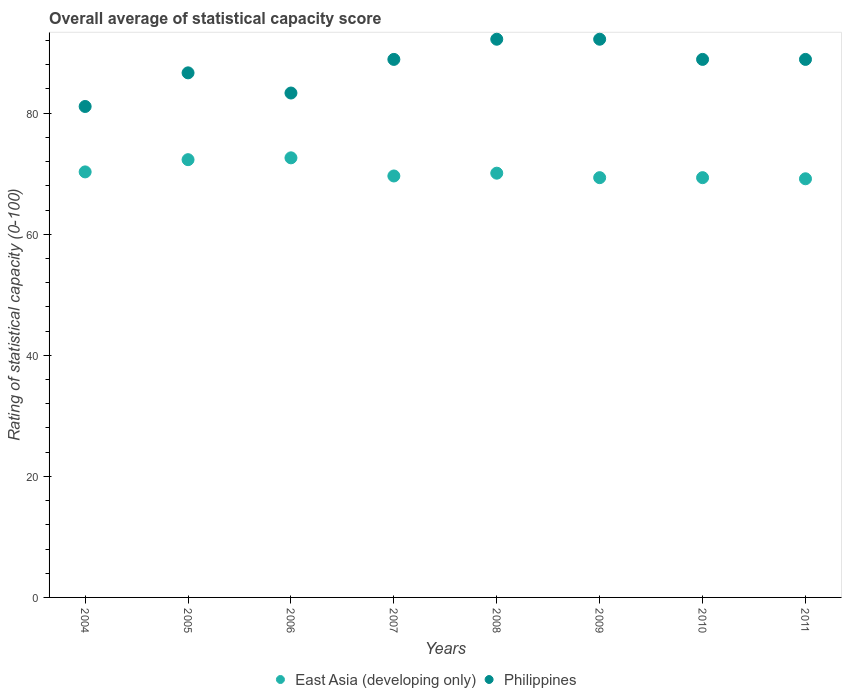How many different coloured dotlines are there?
Provide a succinct answer. 2. Is the number of dotlines equal to the number of legend labels?
Provide a succinct answer. Yes. What is the rating of statistical capacity in Philippines in 2008?
Offer a terse response. 92.22. Across all years, what is the maximum rating of statistical capacity in East Asia (developing only)?
Provide a short and direct response. 72.63. Across all years, what is the minimum rating of statistical capacity in Philippines?
Provide a succinct answer. 81.11. In which year was the rating of statistical capacity in East Asia (developing only) maximum?
Provide a succinct answer. 2006. What is the total rating of statistical capacity in East Asia (developing only) in the graph?
Ensure brevity in your answer.  562.85. What is the difference between the rating of statistical capacity in East Asia (developing only) in 2008 and that in 2009?
Give a very brief answer. 0.74. What is the difference between the rating of statistical capacity in Philippines in 2006 and the rating of statistical capacity in East Asia (developing only) in 2010?
Your answer should be very brief. 13.98. What is the average rating of statistical capacity in Philippines per year?
Ensure brevity in your answer.  87.78. In the year 2011, what is the difference between the rating of statistical capacity in Philippines and rating of statistical capacity in East Asia (developing only)?
Provide a short and direct response. 19.72. In how many years, is the rating of statistical capacity in Philippines greater than 76?
Provide a short and direct response. 8. What is the ratio of the rating of statistical capacity in East Asia (developing only) in 2004 to that in 2009?
Your answer should be very brief. 1.01. Is the difference between the rating of statistical capacity in Philippines in 2004 and 2005 greater than the difference between the rating of statistical capacity in East Asia (developing only) in 2004 and 2005?
Give a very brief answer. No. What is the difference between the highest and the second highest rating of statistical capacity in East Asia (developing only)?
Your answer should be compact. 0.3. What is the difference between the highest and the lowest rating of statistical capacity in East Asia (developing only)?
Ensure brevity in your answer.  3.46. In how many years, is the rating of statistical capacity in Philippines greater than the average rating of statistical capacity in Philippines taken over all years?
Give a very brief answer. 5. Is the sum of the rating of statistical capacity in East Asia (developing only) in 2004 and 2007 greater than the maximum rating of statistical capacity in Philippines across all years?
Your answer should be compact. Yes. Does the rating of statistical capacity in East Asia (developing only) monotonically increase over the years?
Give a very brief answer. No. Is the rating of statistical capacity in East Asia (developing only) strictly greater than the rating of statistical capacity in Philippines over the years?
Make the answer very short. No. How many years are there in the graph?
Your answer should be compact. 8. What is the difference between two consecutive major ticks on the Y-axis?
Provide a succinct answer. 20. Where does the legend appear in the graph?
Provide a succinct answer. Bottom center. How are the legend labels stacked?
Offer a very short reply. Horizontal. What is the title of the graph?
Keep it short and to the point. Overall average of statistical capacity score. What is the label or title of the X-axis?
Keep it short and to the point. Years. What is the label or title of the Y-axis?
Offer a terse response. Rating of statistical capacity (0-100). What is the Rating of statistical capacity (0-100) of East Asia (developing only) in 2004?
Make the answer very short. 70.3. What is the Rating of statistical capacity (0-100) of Philippines in 2004?
Keep it short and to the point. 81.11. What is the Rating of statistical capacity (0-100) in East Asia (developing only) in 2005?
Ensure brevity in your answer.  72.32. What is the Rating of statistical capacity (0-100) of Philippines in 2005?
Give a very brief answer. 86.67. What is the Rating of statistical capacity (0-100) of East Asia (developing only) in 2006?
Your response must be concise. 72.63. What is the Rating of statistical capacity (0-100) of Philippines in 2006?
Offer a terse response. 83.33. What is the Rating of statistical capacity (0-100) in East Asia (developing only) in 2007?
Your answer should be compact. 69.63. What is the Rating of statistical capacity (0-100) of Philippines in 2007?
Provide a short and direct response. 88.89. What is the Rating of statistical capacity (0-100) of East Asia (developing only) in 2008?
Provide a short and direct response. 70.09. What is the Rating of statistical capacity (0-100) in Philippines in 2008?
Keep it short and to the point. 92.22. What is the Rating of statistical capacity (0-100) of East Asia (developing only) in 2009?
Your answer should be compact. 69.35. What is the Rating of statistical capacity (0-100) in Philippines in 2009?
Give a very brief answer. 92.22. What is the Rating of statistical capacity (0-100) in East Asia (developing only) in 2010?
Make the answer very short. 69.35. What is the Rating of statistical capacity (0-100) in Philippines in 2010?
Make the answer very short. 88.89. What is the Rating of statistical capacity (0-100) of East Asia (developing only) in 2011?
Your answer should be very brief. 69.17. What is the Rating of statistical capacity (0-100) in Philippines in 2011?
Offer a very short reply. 88.89. Across all years, what is the maximum Rating of statistical capacity (0-100) in East Asia (developing only)?
Offer a terse response. 72.63. Across all years, what is the maximum Rating of statistical capacity (0-100) of Philippines?
Give a very brief answer. 92.22. Across all years, what is the minimum Rating of statistical capacity (0-100) in East Asia (developing only)?
Your answer should be very brief. 69.17. Across all years, what is the minimum Rating of statistical capacity (0-100) in Philippines?
Offer a terse response. 81.11. What is the total Rating of statistical capacity (0-100) of East Asia (developing only) in the graph?
Provide a short and direct response. 562.85. What is the total Rating of statistical capacity (0-100) of Philippines in the graph?
Offer a terse response. 702.22. What is the difference between the Rating of statistical capacity (0-100) in East Asia (developing only) in 2004 and that in 2005?
Give a very brief answer. -2.02. What is the difference between the Rating of statistical capacity (0-100) of Philippines in 2004 and that in 2005?
Your answer should be compact. -5.56. What is the difference between the Rating of statistical capacity (0-100) of East Asia (developing only) in 2004 and that in 2006?
Keep it short and to the point. -2.32. What is the difference between the Rating of statistical capacity (0-100) of Philippines in 2004 and that in 2006?
Your answer should be very brief. -2.22. What is the difference between the Rating of statistical capacity (0-100) in East Asia (developing only) in 2004 and that in 2007?
Keep it short and to the point. 0.67. What is the difference between the Rating of statistical capacity (0-100) in Philippines in 2004 and that in 2007?
Your answer should be compact. -7.78. What is the difference between the Rating of statistical capacity (0-100) in East Asia (developing only) in 2004 and that in 2008?
Make the answer very short. 0.21. What is the difference between the Rating of statistical capacity (0-100) in Philippines in 2004 and that in 2008?
Ensure brevity in your answer.  -11.11. What is the difference between the Rating of statistical capacity (0-100) of East Asia (developing only) in 2004 and that in 2009?
Give a very brief answer. 0.95. What is the difference between the Rating of statistical capacity (0-100) in Philippines in 2004 and that in 2009?
Provide a short and direct response. -11.11. What is the difference between the Rating of statistical capacity (0-100) in East Asia (developing only) in 2004 and that in 2010?
Keep it short and to the point. 0.95. What is the difference between the Rating of statistical capacity (0-100) in Philippines in 2004 and that in 2010?
Your response must be concise. -7.78. What is the difference between the Rating of statistical capacity (0-100) in East Asia (developing only) in 2004 and that in 2011?
Your answer should be very brief. 1.14. What is the difference between the Rating of statistical capacity (0-100) in Philippines in 2004 and that in 2011?
Keep it short and to the point. -7.78. What is the difference between the Rating of statistical capacity (0-100) of East Asia (developing only) in 2005 and that in 2006?
Give a very brief answer. -0.3. What is the difference between the Rating of statistical capacity (0-100) in East Asia (developing only) in 2005 and that in 2007?
Make the answer very short. 2.69. What is the difference between the Rating of statistical capacity (0-100) of Philippines in 2005 and that in 2007?
Offer a terse response. -2.22. What is the difference between the Rating of statistical capacity (0-100) in East Asia (developing only) in 2005 and that in 2008?
Provide a succinct answer. 2.23. What is the difference between the Rating of statistical capacity (0-100) in Philippines in 2005 and that in 2008?
Provide a short and direct response. -5.56. What is the difference between the Rating of statistical capacity (0-100) of East Asia (developing only) in 2005 and that in 2009?
Give a very brief answer. 2.97. What is the difference between the Rating of statistical capacity (0-100) in Philippines in 2005 and that in 2009?
Keep it short and to the point. -5.56. What is the difference between the Rating of statistical capacity (0-100) of East Asia (developing only) in 2005 and that in 2010?
Offer a terse response. 2.97. What is the difference between the Rating of statistical capacity (0-100) in Philippines in 2005 and that in 2010?
Your answer should be compact. -2.22. What is the difference between the Rating of statistical capacity (0-100) of East Asia (developing only) in 2005 and that in 2011?
Provide a succinct answer. 3.16. What is the difference between the Rating of statistical capacity (0-100) of Philippines in 2005 and that in 2011?
Give a very brief answer. -2.22. What is the difference between the Rating of statistical capacity (0-100) of East Asia (developing only) in 2006 and that in 2007?
Your answer should be compact. 3. What is the difference between the Rating of statistical capacity (0-100) in Philippines in 2006 and that in 2007?
Give a very brief answer. -5.56. What is the difference between the Rating of statistical capacity (0-100) in East Asia (developing only) in 2006 and that in 2008?
Your response must be concise. 2.53. What is the difference between the Rating of statistical capacity (0-100) in Philippines in 2006 and that in 2008?
Your response must be concise. -8.89. What is the difference between the Rating of statistical capacity (0-100) of East Asia (developing only) in 2006 and that in 2009?
Your answer should be compact. 3.27. What is the difference between the Rating of statistical capacity (0-100) in Philippines in 2006 and that in 2009?
Provide a short and direct response. -8.89. What is the difference between the Rating of statistical capacity (0-100) of East Asia (developing only) in 2006 and that in 2010?
Your answer should be compact. 3.27. What is the difference between the Rating of statistical capacity (0-100) in Philippines in 2006 and that in 2010?
Your answer should be compact. -5.56. What is the difference between the Rating of statistical capacity (0-100) in East Asia (developing only) in 2006 and that in 2011?
Ensure brevity in your answer.  3.46. What is the difference between the Rating of statistical capacity (0-100) in Philippines in 2006 and that in 2011?
Keep it short and to the point. -5.56. What is the difference between the Rating of statistical capacity (0-100) in East Asia (developing only) in 2007 and that in 2008?
Your answer should be very brief. -0.46. What is the difference between the Rating of statistical capacity (0-100) of Philippines in 2007 and that in 2008?
Keep it short and to the point. -3.33. What is the difference between the Rating of statistical capacity (0-100) in East Asia (developing only) in 2007 and that in 2009?
Your answer should be very brief. 0.28. What is the difference between the Rating of statistical capacity (0-100) in Philippines in 2007 and that in 2009?
Offer a very short reply. -3.33. What is the difference between the Rating of statistical capacity (0-100) in East Asia (developing only) in 2007 and that in 2010?
Give a very brief answer. 0.28. What is the difference between the Rating of statistical capacity (0-100) in East Asia (developing only) in 2007 and that in 2011?
Your response must be concise. 0.46. What is the difference between the Rating of statistical capacity (0-100) in Philippines in 2007 and that in 2011?
Your answer should be compact. 0. What is the difference between the Rating of statistical capacity (0-100) of East Asia (developing only) in 2008 and that in 2009?
Offer a very short reply. 0.74. What is the difference between the Rating of statistical capacity (0-100) in Philippines in 2008 and that in 2009?
Make the answer very short. 0. What is the difference between the Rating of statistical capacity (0-100) in East Asia (developing only) in 2008 and that in 2010?
Ensure brevity in your answer.  0.74. What is the difference between the Rating of statistical capacity (0-100) of Philippines in 2008 and that in 2010?
Make the answer very short. 3.33. What is the difference between the Rating of statistical capacity (0-100) of East Asia (developing only) in 2008 and that in 2011?
Give a very brief answer. 0.93. What is the difference between the Rating of statistical capacity (0-100) of Philippines in 2008 and that in 2011?
Make the answer very short. 3.33. What is the difference between the Rating of statistical capacity (0-100) of East Asia (developing only) in 2009 and that in 2011?
Your answer should be compact. 0.19. What is the difference between the Rating of statistical capacity (0-100) in East Asia (developing only) in 2010 and that in 2011?
Offer a very short reply. 0.19. What is the difference between the Rating of statistical capacity (0-100) in Philippines in 2010 and that in 2011?
Provide a short and direct response. 0. What is the difference between the Rating of statistical capacity (0-100) of East Asia (developing only) in 2004 and the Rating of statistical capacity (0-100) of Philippines in 2005?
Your answer should be very brief. -16.36. What is the difference between the Rating of statistical capacity (0-100) of East Asia (developing only) in 2004 and the Rating of statistical capacity (0-100) of Philippines in 2006?
Ensure brevity in your answer.  -13.03. What is the difference between the Rating of statistical capacity (0-100) of East Asia (developing only) in 2004 and the Rating of statistical capacity (0-100) of Philippines in 2007?
Provide a short and direct response. -18.59. What is the difference between the Rating of statistical capacity (0-100) of East Asia (developing only) in 2004 and the Rating of statistical capacity (0-100) of Philippines in 2008?
Your response must be concise. -21.92. What is the difference between the Rating of statistical capacity (0-100) in East Asia (developing only) in 2004 and the Rating of statistical capacity (0-100) in Philippines in 2009?
Offer a very short reply. -21.92. What is the difference between the Rating of statistical capacity (0-100) of East Asia (developing only) in 2004 and the Rating of statistical capacity (0-100) of Philippines in 2010?
Your answer should be compact. -18.59. What is the difference between the Rating of statistical capacity (0-100) in East Asia (developing only) in 2004 and the Rating of statistical capacity (0-100) in Philippines in 2011?
Give a very brief answer. -18.59. What is the difference between the Rating of statistical capacity (0-100) of East Asia (developing only) in 2005 and the Rating of statistical capacity (0-100) of Philippines in 2006?
Ensure brevity in your answer.  -11.01. What is the difference between the Rating of statistical capacity (0-100) of East Asia (developing only) in 2005 and the Rating of statistical capacity (0-100) of Philippines in 2007?
Your answer should be compact. -16.57. What is the difference between the Rating of statistical capacity (0-100) in East Asia (developing only) in 2005 and the Rating of statistical capacity (0-100) in Philippines in 2008?
Your answer should be very brief. -19.9. What is the difference between the Rating of statistical capacity (0-100) of East Asia (developing only) in 2005 and the Rating of statistical capacity (0-100) of Philippines in 2009?
Ensure brevity in your answer.  -19.9. What is the difference between the Rating of statistical capacity (0-100) of East Asia (developing only) in 2005 and the Rating of statistical capacity (0-100) of Philippines in 2010?
Give a very brief answer. -16.57. What is the difference between the Rating of statistical capacity (0-100) of East Asia (developing only) in 2005 and the Rating of statistical capacity (0-100) of Philippines in 2011?
Keep it short and to the point. -16.57. What is the difference between the Rating of statistical capacity (0-100) in East Asia (developing only) in 2006 and the Rating of statistical capacity (0-100) in Philippines in 2007?
Your answer should be compact. -16.26. What is the difference between the Rating of statistical capacity (0-100) of East Asia (developing only) in 2006 and the Rating of statistical capacity (0-100) of Philippines in 2008?
Ensure brevity in your answer.  -19.6. What is the difference between the Rating of statistical capacity (0-100) in East Asia (developing only) in 2006 and the Rating of statistical capacity (0-100) in Philippines in 2009?
Your answer should be compact. -19.6. What is the difference between the Rating of statistical capacity (0-100) in East Asia (developing only) in 2006 and the Rating of statistical capacity (0-100) in Philippines in 2010?
Offer a terse response. -16.26. What is the difference between the Rating of statistical capacity (0-100) of East Asia (developing only) in 2006 and the Rating of statistical capacity (0-100) of Philippines in 2011?
Make the answer very short. -16.26. What is the difference between the Rating of statistical capacity (0-100) of East Asia (developing only) in 2007 and the Rating of statistical capacity (0-100) of Philippines in 2008?
Ensure brevity in your answer.  -22.59. What is the difference between the Rating of statistical capacity (0-100) in East Asia (developing only) in 2007 and the Rating of statistical capacity (0-100) in Philippines in 2009?
Your answer should be very brief. -22.59. What is the difference between the Rating of statistical capacity (0-100) in East Asia (developing only) in 2007 and the Rating of statistical capacity (0-100) in Philippines in 2010?
Keep it short and to the point. -19.26. What is the difference between the Rating of statistical capacity (0-100) of East Asia (developing only) in 2007 and the Rating of statistical capacity (0-100) of Philippines in 2011?
Provide a succinct answer. -19.26. What is the difference between the Rating of statistical capacity (0-100) in East Asia (developing only) in 2008 and the Rating of statistical capacity (0-100) in Philippines in 2009?
Ensure brevity in your answer.  -22.13. What is the difference between the Rating of statistical capacity (0-100) of East Asia (developing only) in 2008 and the Rating of statistical capacity (0-100) of Philippines in 2010?
Give a very brief answer. -18.8. What is the difference between the Rating of statistical capacity (0-100) of East Asia (developing only) in 2008 and the Rating of statistical capacity (0-100) of Philippines in 2011?
Provide a short and direct response. -18.8. What is the difference between the Rating of statistical capacity (0-100) of East Asia (developing only) in 2009 and the Rating of statistical capacity (0-100) of Philippines in 2010?
Your answer should be very brief. -19.54. What is the difference between the Rating of statistical capacity (0-100) of East Asia (developing only) in 2009 and the Rating of statistical capacity (0-100) of Philippines in 2011?
Make the answer very short. -19.54. What is the difference between the Rating of statistical capacity (0-100) in East Asia (developing only) in 2010 and the Rating of statistical capacity (0-100) in Philippines in 2011?
Offer a very short reply. -19.54. What is the average Rating of statistical capacity (0-100) of East Asia (developing only) per year?
Make the answer very short. 70.36. What is the average Rating of statistical capacity (0-100) of Philippines per year?
Offer a terse response. 87.78. In the year 2004, what is the difference between the Rating of statistical capacity (0-100) in East Asia (developing only) and Rating of statistical capacity (0-100) in Philippines?
Provide a succinct answer. -10.81. In the year 2005, what is the difference between the Rating of statistical capacity (0-100) in East Asia (developing only) and Rating of statistical capacity (0-100) in Philippines?
Ensure brevity in your answer.  -14.34. In the year 2006, what is the difference between the Rating of statistical capacity (0-100) of East Asia (developing only) and Rating of statistical capacity (0-100) of Philippines?
Keep it short and to the point. -10.71. In the year 2007, what is the difference between the Rating of statistical capacity (0-100) of East Asia (developing only) and Rating of statistical capacity (0-100) of Philippines?
Give a very brief answer. -19.26. In the year 2008, what is the difference between the Rating of statistical capacity (0-100) of East Asia (developing only) and Rating of statistical capacity (0-100) of Philippines?
Give a very brief answer. -22.13. In the year 2009, what is the difference between the Rating of statistical capacity (0-100) of East Asia (developing only) and Rating of statistical capacity (0-100) of Philippines?
Ensure brevity in your answer.  -22.87. In the year 2010, what is the difference between the Rating of statistical capacity (0-100) in East Asia (developing only) and Rating of statistical capacity (0-100) in Philippines?
Give a very brief answer. -19.54. In the year 2011, what is the difference between the Rating of statistical capacity (0-100) in East Asia (developing only) and Rating of statistical capacity (0-100) in Philippines?
Offer a terse response. -19.72. What is the ratio of the Rating of statistical capacity (0-100) of East Asia (developing only) in 2004 to that in 2005?
Give a very brief answer. 0.97. What is the ratio of the Rating of statistical capacity (0-100) in Philippines in 2004 to that in 2005?
Your answer should be compact. 0.94. What is the ratio of the Rating of statistical capacity (0-100) in Philippines in 2004 to that in 2006?
Your response must be concise. 0.97. What is the ratio of the Rating of statistical capacity (0-100) of East Asia (developing only) in 2004 to that in 2007?
Your answer should be compact. 1.01. What is the ratio of the Rating of statistical capacity (0-100) in Philippines in 2004 to that in 2007?
Keep it short and to the point. 0.91. What is the ratio of the Rating of statistical capacity (0-100) in East Asia (developing only) in 2004 to that in 2008?
Provide a succinct answer. 1. What is the ratio of the Rating of statistical capacity (0-100) of Philippines in 2004 to that in 2008?
Provide a succinct answer. 0.88. What is the ratio of the Rating of statistical capacity (0-100) of East Asia (developing only) in 2004 to that in 2009?
Your response must be concise. 1.01. What is the ratio of the Rating of statistical capacity (0-100) in Philippines in 2004 to that in 2009?
Provide a succinct answer. 0.88. What is the ratio of the Rating of statistical capacity (0-100) in East Asia (developing only) in 2004 to that in 2010?
Give a very brief answer. 1.01. What is the ratio of the Rating of statistical capacity (0-100) in Philippines in 2004 to that in 2010?
Your answer should be very brief. 0.91. What is the ratio of the Rating of statistical capacity (0-100) in East Asia (developing only) in 2004 to that in 2011?
Give a very brief answer. 1.02. What is the ratio of the Rating of statistical capacity (0-100) in Philippines in 2004 to that in 2011?
Provide a short and direct response. 0.91. What is the ratio of the Rating of statistical capacity (0-100) of East Asia (developing only) in 2005 to that in 2006?
Keep it short and to the point. 1. What is the ratio of the Rating of statistical capacity (0-100) in East Asia (developing only) in 2005 to that in 2007?
Offer a terse response. 1.04. What is the ratio of the Rating of statistical capacity (0-100) of Philippines in 2005 to that in 2007?
Ensure brevity in your answer.  0.97. What is the ratio of the Rating of statistical capacity (0-100) in East Asia (developing only) in 2005 to that in 2008?
Keep it short and to the point. 1.03. What is the ratio of the Rating of statistical capacity (0-100) in Philippines in 2005 to that in 2008?
Keep it short and to the point. 0.94. What is the ratio of the Rating of statistical capacity (0-100) in East Asia (developing only) in 2005 to that in 2009?
Keep it short and to the point. 1.04. What is the ratio of the Rating of statistical capacity (0-100) of Philippines in 2005 to that in 2009?
Provide a succinct answer. 0.94. What is the ratio of the Rating of statistical capacity (0-100) in East Asia (developing only) in 2005 to that in 2010?
Your response must be concise. 1.04. What is the ratio of the Rating of statistical capacity (0-100) in Philippines in 2005 to that in 2010?
Provide a short and direct response. 0.97. What is the ratio of the Rating of statistical capacity (0-100) of East Asia (developing only) in 2005 to that in 2011?
Keep it short and to the point. 1.05. What is the ratio of the Rating of statistical capacity (0-100) in East Asia (developing only) in 2006 to that in 2007?
Your response must be concise. 1.04. What is the ratio of the Rating of statistical capacity (0-100) of Philippines in 2006 to that in 2007?
Your answer should be compact. 0.94. What is the ratio of the Rating of statistical capacity (0-100) in East Asia (developing only) in 2006 to that in 2008?
Your response must be concise. 1.04. What is the ratio of the Rating of statistical capacity (0-100) in Philippines in 2006 to that in 2008?
Offer a terse response. 0.9. What is the ratio of the Rating of statistical capacity (0-100) in East Asia (developing only) in 2006 to that in 2009?
Give a very brief answer. 1.05. What is the ratio of the Rating of statistical capacity (0-100) in Philippines in 2006 to that in 2009?
Your answer should be very brief. 0.9. What is the ratio of the Rating of statistical capacity (0-100) in East Asia (developing only) in 2006 to that in 2010?
Keep it short and to the point. 1.05. What is the ratio of the Rating of statistical capacity (0-100) of East Asia (developing only) in 2006 to that in 2011?
Your answer should be compact. 1.05. What is the ratio of the Rating of statistical capacity (0-100) in Philippines in 2007 to that in 2008?
Ensure brevity in your answer.  0.96. What is the ratio of the Rating of statistical capacity (0-100) in Philippines in 2007 to that in 2009?
Ensure brevity in your answer.  0.96. What is the ratio of the Rating of statistical capacity (0-100) of Philippines in 2007 to that in 2010?
Offer a very short reply. 1. What is the ratio of the Rating of statistical capacity (0-100) of Philippines in 2007 to that in 2011?
Provide a short and direct response. 1. What is the ratio of the Rating of statistical capacity (0-100) of East Asia (developing only) in 2008 to that in 2009?
Offer a very short reply. 1.01. What is the ratio of the Rating of statistical capacity (0-100) in Philippines in 2008 to that in 2009?
Make the answer very short. 1. What is the ratio of the Rating of statistical capacity (0-100) in East Asia (developing only) in 2008 to that in 2010?
Offer a very short reply. 1.01. What is the ratio of the Rating of statistical capacity (0-100) of Philippines in 2008 to that in 2010?
Give a very brief answer. 1.04. What is the ratio of the Rating of statistical capacity (0-100) of East Asia (developing only) in 2008 to that in 2011?
Make the answer very short. 1.01. What is the ratio of the Rating of statistical capacity (0-100) of Philippines in 2008 to that in 2011?
Provide a short and direct response. 1.04. What is the ratio of the Rating of statistical capacity (0-100) of Philippines in 2009 to that in 2010?
Offer a terse response. 1.04. What is the ratio of the Rating of statistical capacity (0-100) of Philippines in 2009 to that in 2011?
Keep it short and to the point. 1.04. What is the ratio of the Rating of statistical capacity (0-100) of East Asia (developing only) in 2010 to that in 2011?
Give a very brief answer. 1. What is the ratio of the Rating of statistical capacity (0-100) in Philippines in 2010 to that in 2011?
Provide a short and direct response. 1. What is the difference between the highest and the second highest Rating of statistical capacity (0-100) of East Asia (developing only)?
Your response must be concise. 0.3. What is the difference between the highest and the lowest Rating of statistical capacity (0-100) in East Asia (developing only)?
Offer a terse response. 3.46. What is the difference between the highest and the lowest Rating of statistical capacity (0-100) of Philippines?
Offer a very short reply. 11.11. 